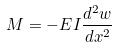<formula> <loc_0><loc_0><loc_500><loc_500>M = - E I \frac { d ^ { 2 } w } { d x ^ { 2 } }</formula> 